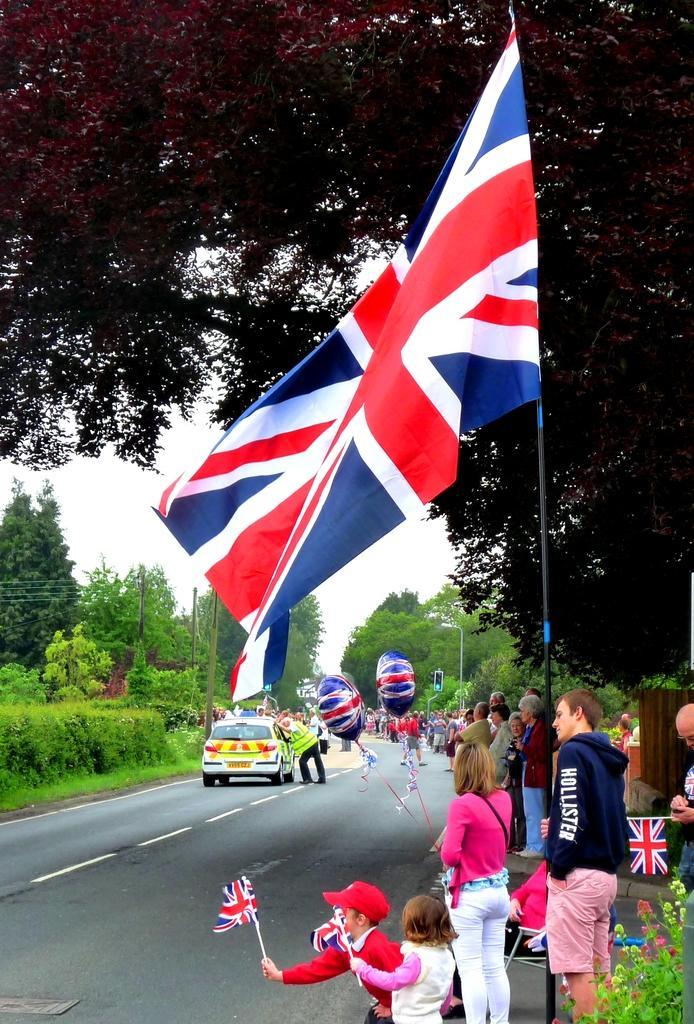Could you give a brief overview of what you see in this image? In this image I can see few persons standing and holding few flags which are red, white and blue in color. I can see the road, few vehicles on the road, few persons standing on the road, few trees which are green in color and the sky in the background. 